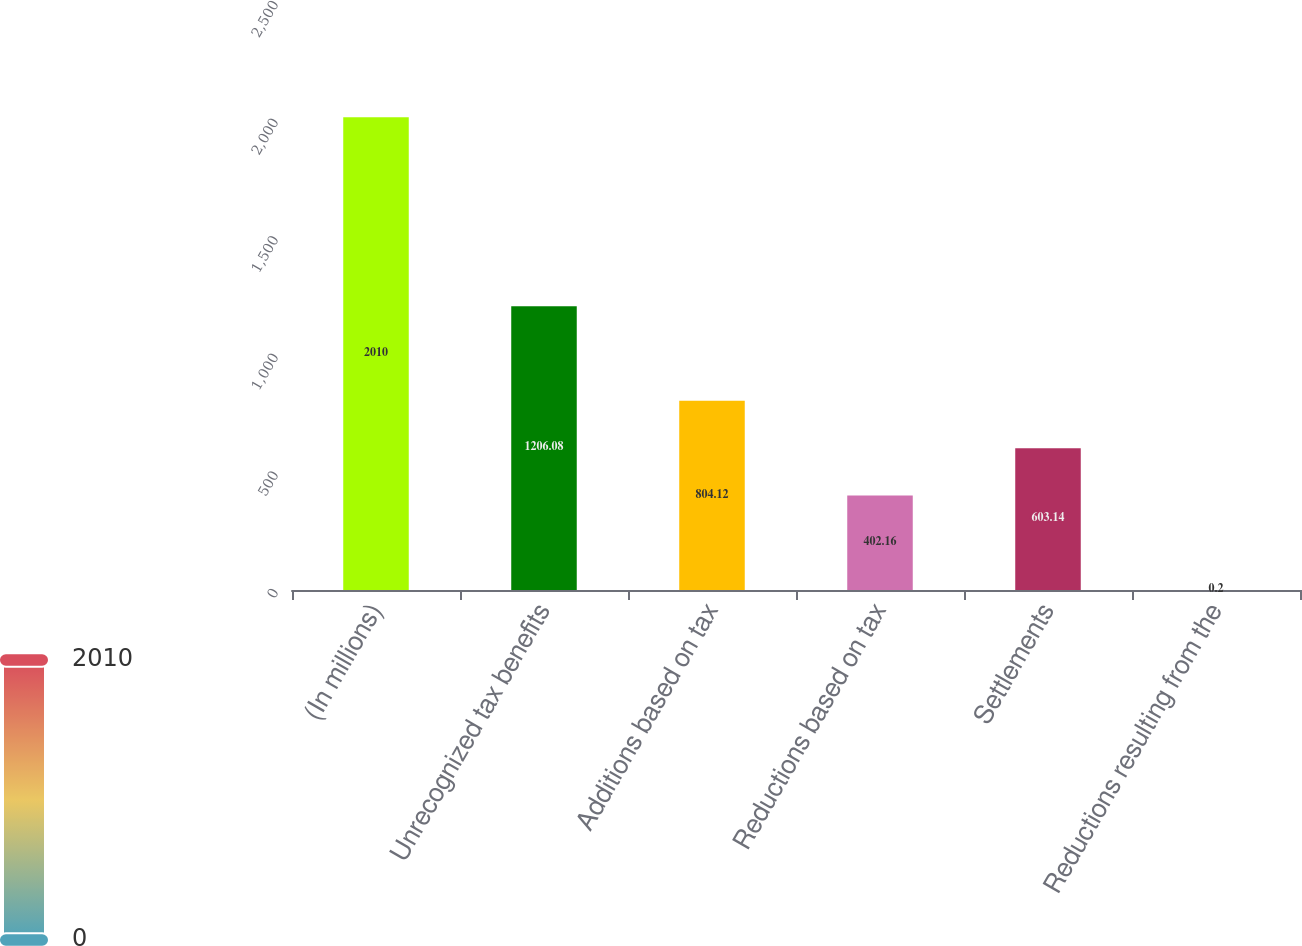Convert chart. <chart><loc_0><loc_0><loc_500><loc_500><bar_chart><fcel>(In millions)<fcel>Unrecognized tax benefits<fcel>Additions based on tax<fcel>Reductions based on tax<fcel>Settlements<fcel>Reductions resulting from the<nl><fcel>2010<fcel>1206.08<fcel>804.12<fcel>402.16<fcel>603.14<fcel>0.2<nl></chart> 